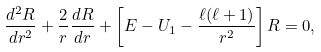<formula> <loc_0><loc_0><loc_500><loc_500>\frac { d ^ { 2 } R } { d r ^ { 2 } } + \frac { 2 } { r } \frac { d R } { d r } + \left [ E - U _ { 1 } - \frac { \ell ( \ell + 1 ) } { r ^ { 2 } } \right ] R = 0 ,</formula> 